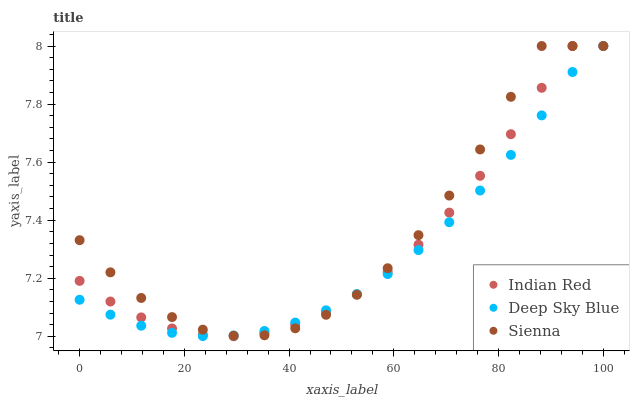Does Deep Sky Blue have the minimum area under the curve?
Answer yes or no. Yes. Does Sienna have the maximum area under the curve?
Answer yes or no. Yes. Does Indian Red have the minimum area under the curve?
Answer yes or no. No. Does Indian Red have the maximum area under the curve?
Answer yes or no. No. Is Deep Sky Blue the smoothest?
Answer yes or no. Yes. Is Sienna the roughest?
Answer yes or no. Yes. Is Indian Red the smoothest?
Answer yes or no. No. Is Indian Red the roughest?
Answer yes or no. No. Does Indian Red have the lowest value?
Answer yes or no. Yes. Does Deep Sky Blue have the lowest value?
Answer yes or no. No. Does Indian Red have the highest value?
Answer yes or no. Yes. Does Sienna intersect Indian Red?
Answer yes or no. Yes. Is Sienna less than Indian Red?
Answer yes or no. No. Is Sienna greater than Indian Red?
Answer yes or no. No. 